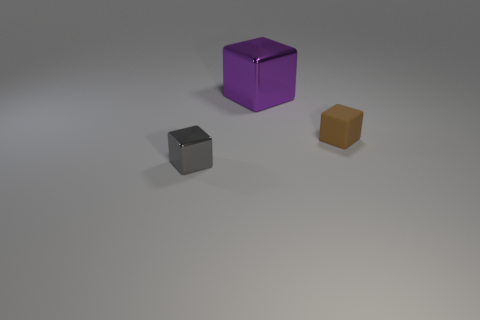Subtract all cyan cubes. Subtract all red cylinders. How many cubes are left? 3 Add 1 brown rubber blocks. How many objects exist? 4 Add 1 gray things. How many gray things are left? 2 Add 2 large purple blocks. How many large purple blocks exist? 3 Subtract 1 brown cubes. How many objects are left? 2 Subtract all purple metal blocks. Subtract all small green cylinders. How many objects are left? 2 